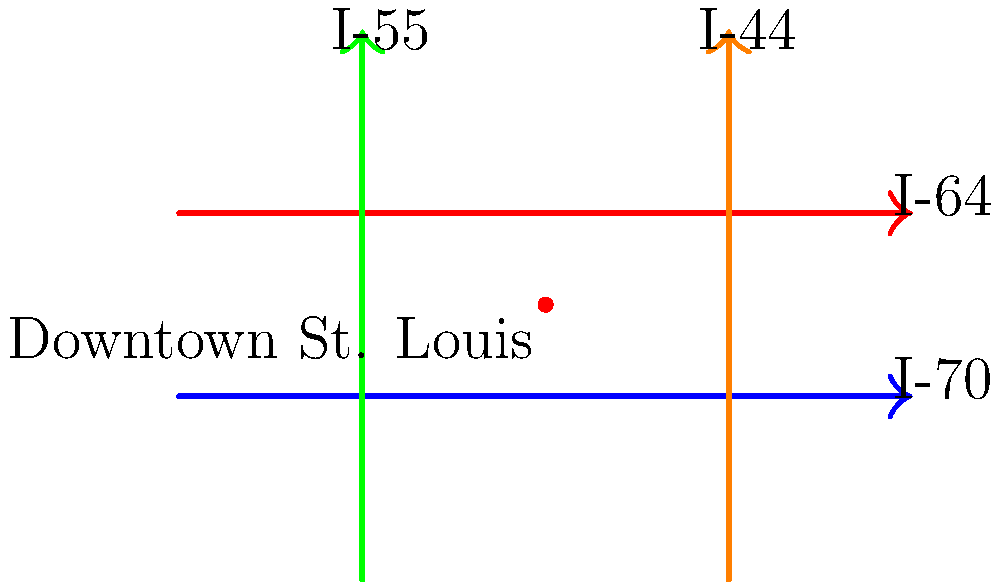Based on the simplified highway map of St. Louis, which two interstate highways form a loop around the downtown area? To answer this question, let's analyze the highway map step-by-step:

1. The map shows four major interstate highways intersecting in the St. Louis metropolitan area: I-70, I-64, I-55, and I-44.

2. I-70 (blue) runs horizontally across the lower part of the map.
3. I-64 (red) runs horizontally across the upper part of the map.
4. I-55 (green) runs vertically on the left side of the map.
5. I-44 (orange) runs vertically on the right side of the map.

6. Downtown St. Louis is marked with a red dot near the center of the map.

7. Observing the layout, we can see that I-64 passes above downtown, while I-70 passes below it.

8. These two highways (I-64 and I-70) form a rough loop around the downtown area, with I-64 to the north and I-70 to the south.

9. I-55 and I-44 do not form part of this loop, as they run vertically and do not encircle the downtown area.

Therefore, the two interstate highways that form a loop around the downtown area are I-64 and I-70.
Answer: I-64 and I-70 